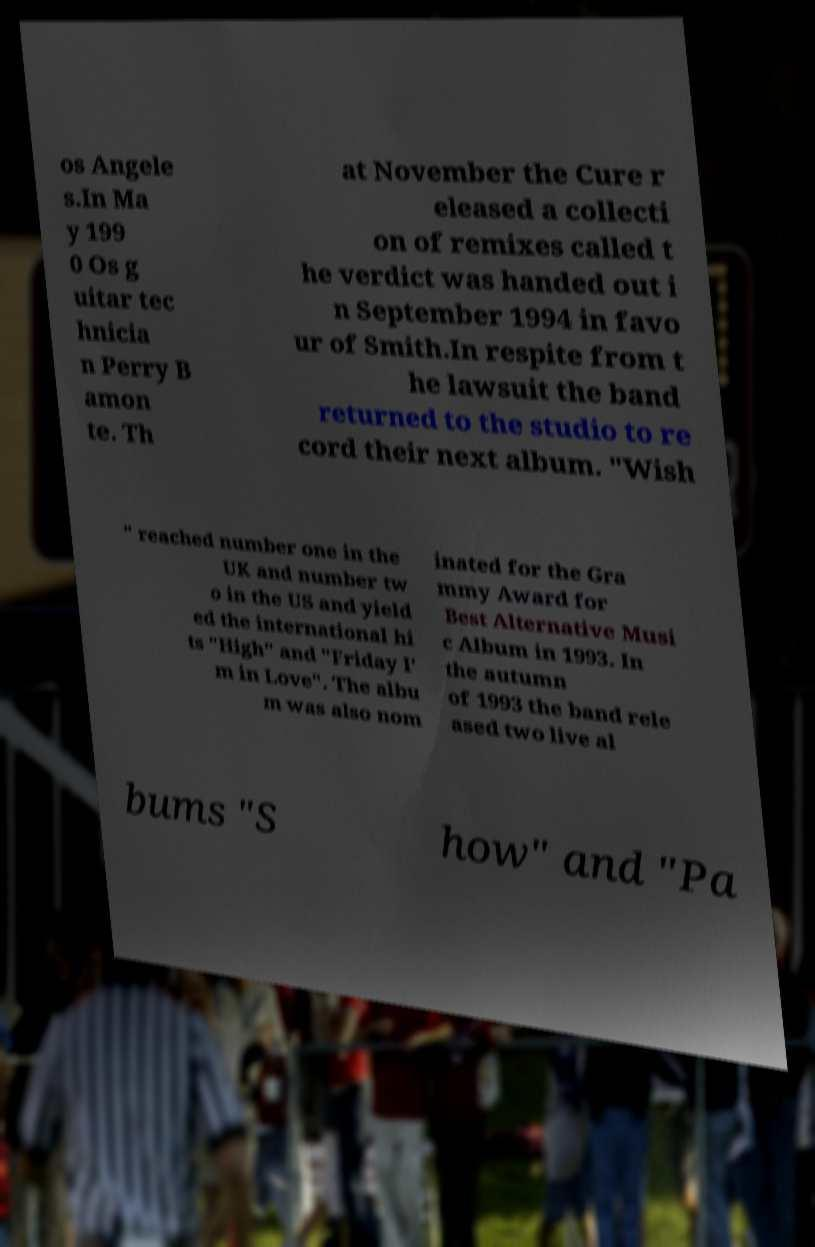Could you extract and type out the text from this image? os Angele s.In Ma y 199 0 Os g uitar tec hnicia n Perry B amon te. Th at November the Cure r eleased a collecti on of remixes called t he verdict was handed out i n September 1994 in favo ur of Smith.In respite from t he lawsuit the band returned to the studio to re cord their next album. "Wish " reached number one in the UK and number tw o in the US and yield ed the international hi ts "High" and "Friday I' m in Love". The albu m was also nom inated for the Gra mmy Award for Best Alternative Musi c Album in 1993. In the autumn of 1993 the band rele ased two live al bums "S how" and "Pa 